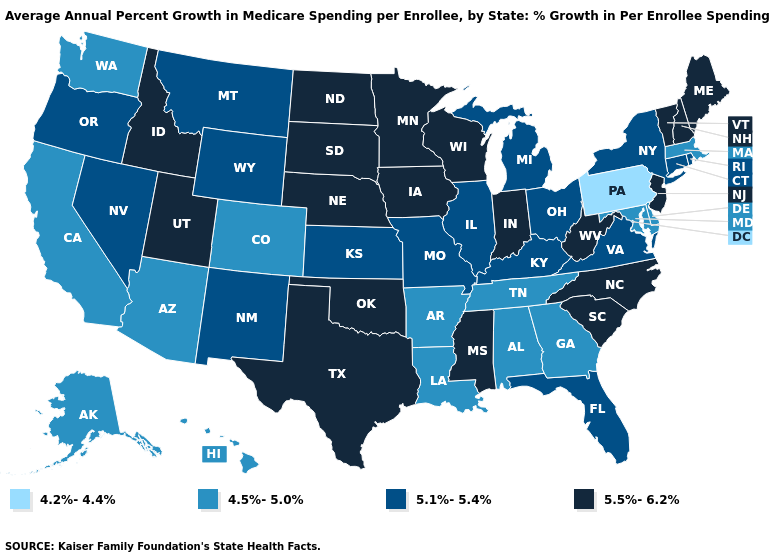What is the value of Illinois?
Quick response, please. 5.1%-5.4%. Name the states that have a value in the range 5.5%-6.2%?
Be succinct. Idaho, Indiana, Iowa, Maine, Minnesota, Mississippi, Nebraska, New Hampshire, New Jersey, North Carolina, North Dakota, Oklahoma, South Carolina, South Dakota, Texas, Utah, Vermont, West Virginia, Wisconsin. Name the states that have a value in the range 4.5%-5.0%?
Quick response, please. Alabama, Alaska, Arizona, Arkansas, California, Colorado, Delaware, Georgia, Hawaii, Louisiana, Maryland, Massachusetts, Tennessee, Washington. What is the value of Delaware?
Quick response, please. 4.5%-5.0%. What is the lowest value in the MidWest?
Answer briefly. 5.1%-5.4%. Among the states that border Colorado , does Arizona have the lowest value?
Answer briefly. Yes. What is the value of Oregon?
Give a very brief answer. 5.1%-5.4%. Does Pennsylvania have the lowest value in the USA?
Write a very short answer. Yes. Name the states that have a value in the range 5.1%-5.4%?
Short answer required. Connecticut, Florida, Illinois, Kansas, Kentucky, Michigan, Missouri, Montana, Nevada, New Mexico, New York, Ohio, Oregon, Rhode Island, Virginia, Wyoming. Does Colorado have the same value as West Virginia?
Answer briefly. No. What is the lowest value in the USA?
Be succinct. 4.2%-4.4%. Name the states that have a value in the range 5.5%-6.2%?
Write a very short answer. Idaho, Indiana, Iowa, Maine, Minnesota, Mississippi, Nebraska, New Hampshire, New Jersey, North Carolina, North Dakota, Oklahoma, South Carolina, South Dakota, Texas, Utah, Vermont, West Virginia, Wisconsin. What is the lowest value in the South?
Be succinct. 4.5%-5.0%. Does Connecticut have a higher value than Arkansas?
Keep it brief. Yes. 